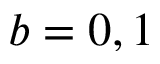Convert formula to latex. <formula><loc_0><loc_0><loc_500><loc_500>b = 0 , 1</formula> 